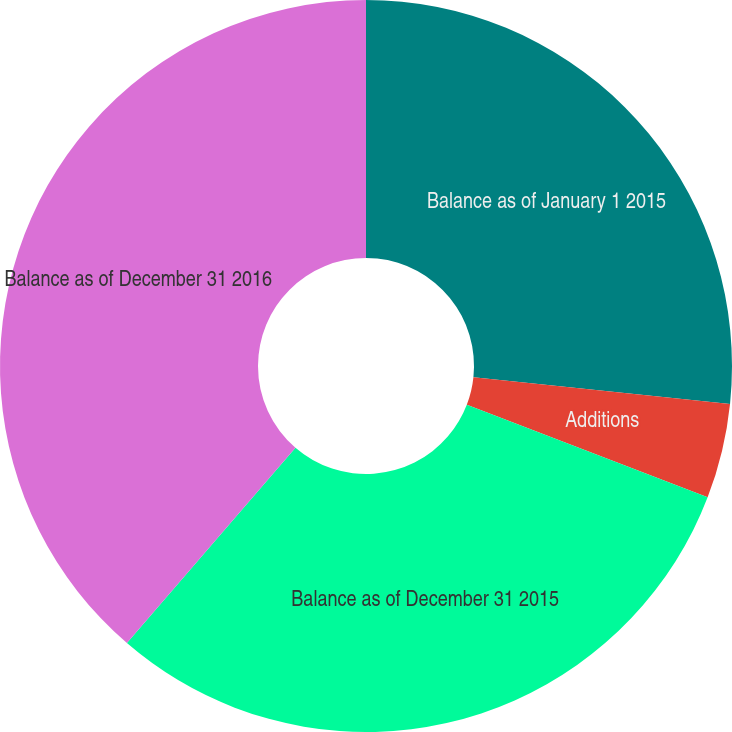<chart> <loc_0><loc_0><loc_500><loc_500><pie_chart><fcel>Balance as of January 1 2015<fcel>Additions<fcel>Balance as of December 31 2015<fcel>Balance as of December 31 2016<nl><fcel>26.65%<fcel>4.19%<fcel>30.49%<fcel>38.67%<nl></chart> 